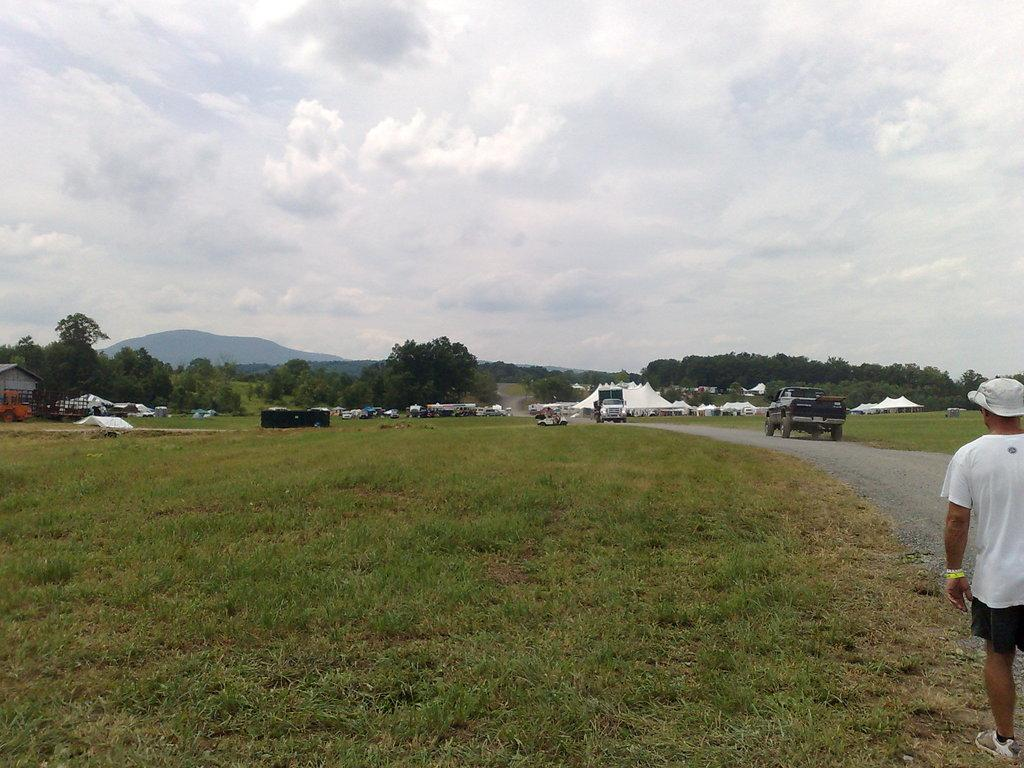What is the person in the image wearing on their head? The person in the image is wearing a cap. What type of terrain is visible in the image? There is grass and a path visible in the image. What type of temporary shelter can be seen in the image? There are tents in the image. What type of transportation is present in the image? There are vehicles in the image. What can be seen in the background of the image? There are trees and the sky visible in the background of the image. What is the condition of the sky in the image? Clouds are present in the sky. What type of stew is being served in the image? There is no stew present in the image. What type of ring is the person wearing on their finger in the image? There is no ring visible on the person's finger in the image. 